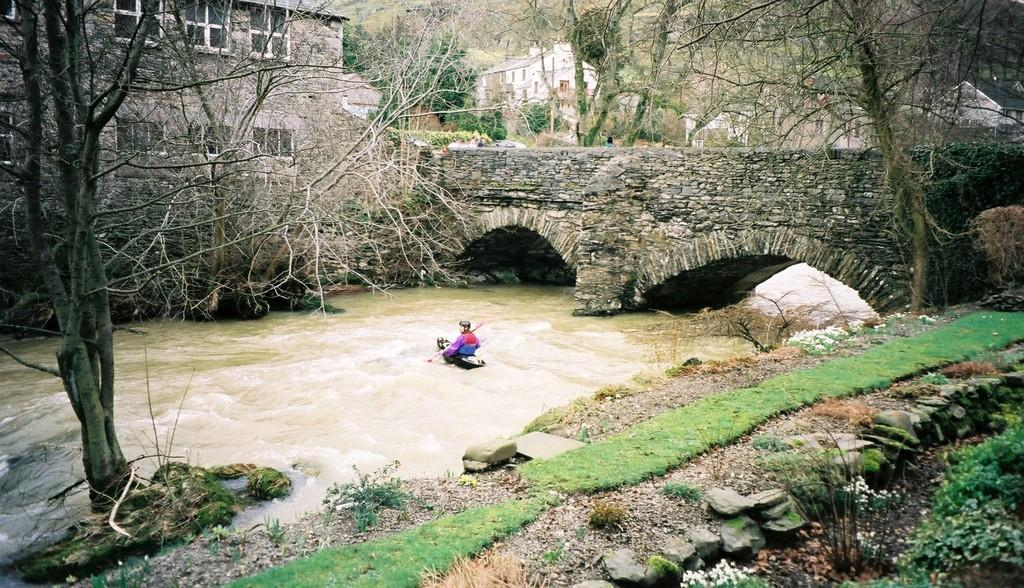What is the person in the image doing? There is a person riding a boat in the image. Where is the boat located? The boat is on water in the image. What type of vegetation can be seen in the image? There are plants and grass visible in the image. What can be seen in the background of the image? There are buildings and trees in the background of the image. What type of liquid is the goat drinking in the image? There is no goat present in the image, and therefore no such activity can be observed. 